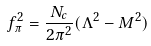<formula> <loc_0><loc_0><loc_500><loc_500>f _ { \pi } ^ { 2 } = \frac { N _ { c } } { 2 \pi ^ { 2 } } ( \Lambda ^ { 2 } - M ^ { 2 } )</formula> 